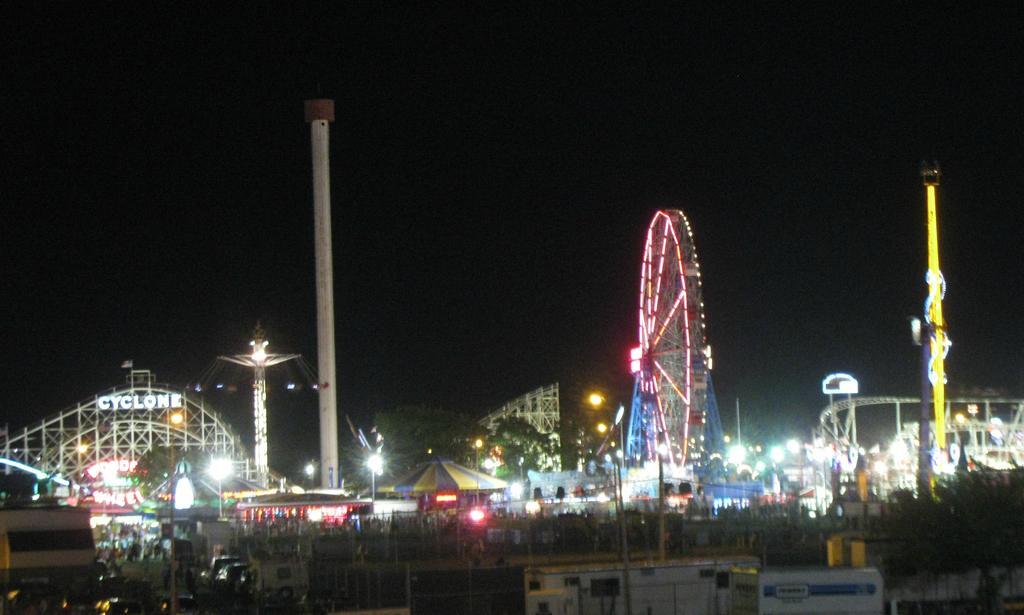In one or two sentences, can you explain what this image depicts? This is the aerial view image of carnival with giant wheel in the middle and roller coaster on the right side, in the front there are many stores with people walking on the land. 